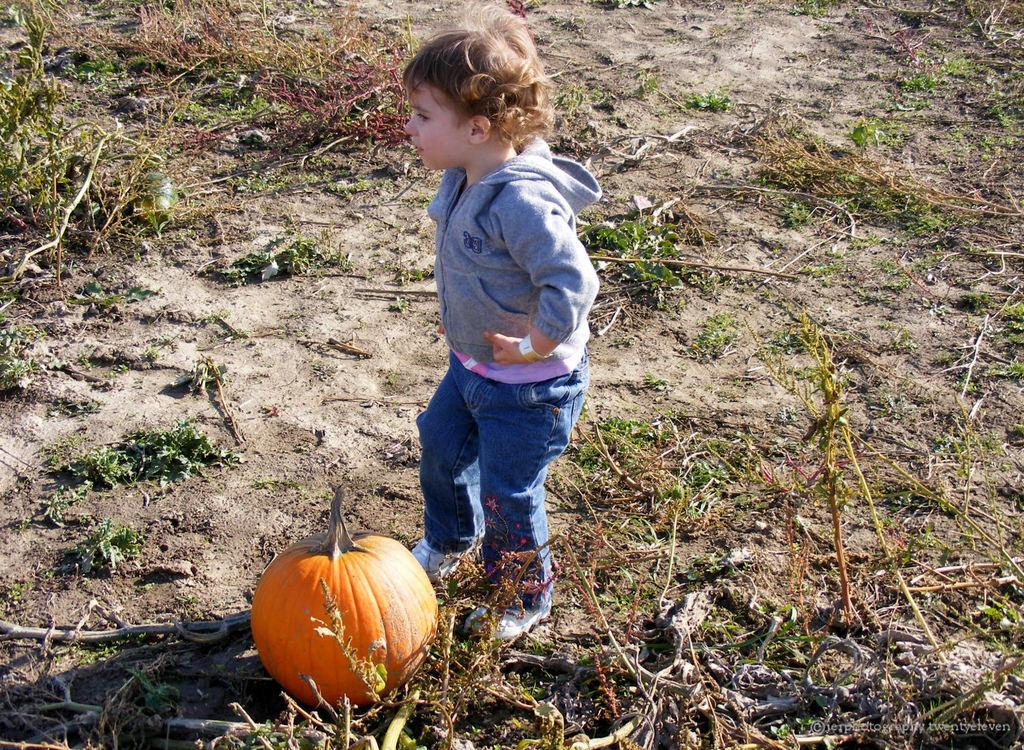What is the main subject of the image? There is a kid in the center of the image. What is the kid wearing? The kid is wearing a coat. What is the kid's posture in the image? The kid is standing. What object can be seen at the bottom of the image? There is a pumpkin at the bottom of the image. What type of vegetation is present on the ground? There are plants on the ground. What type of lettuce is growing next to the kid in the image? There is no lettuce present in the image. Can you identify the animal that the kid is petting in the image? There is no animal present in the image. 